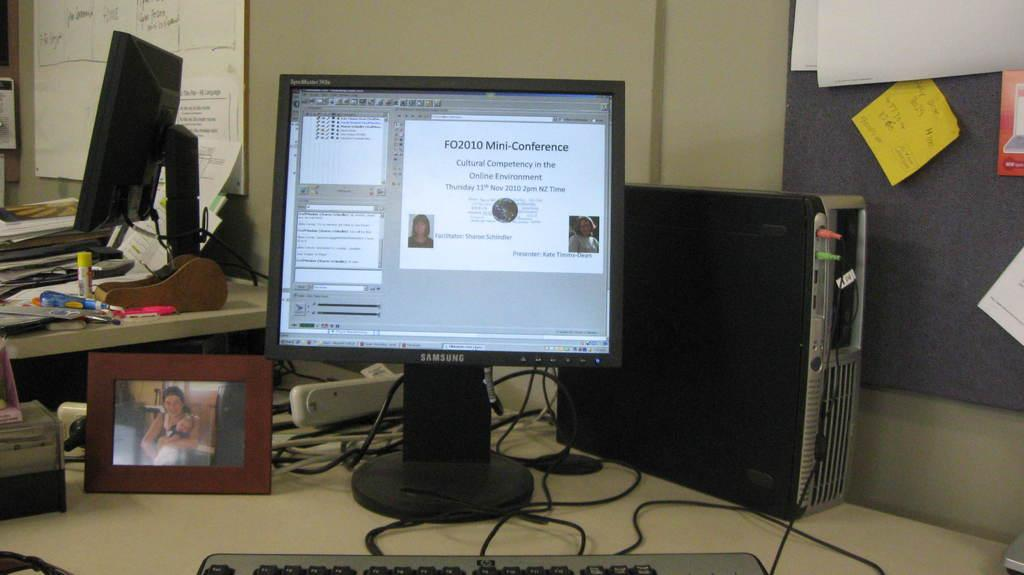Provide a one-sentence caption for the provided image. A monitor with information concerning the FO2010 Mini-Conference. 